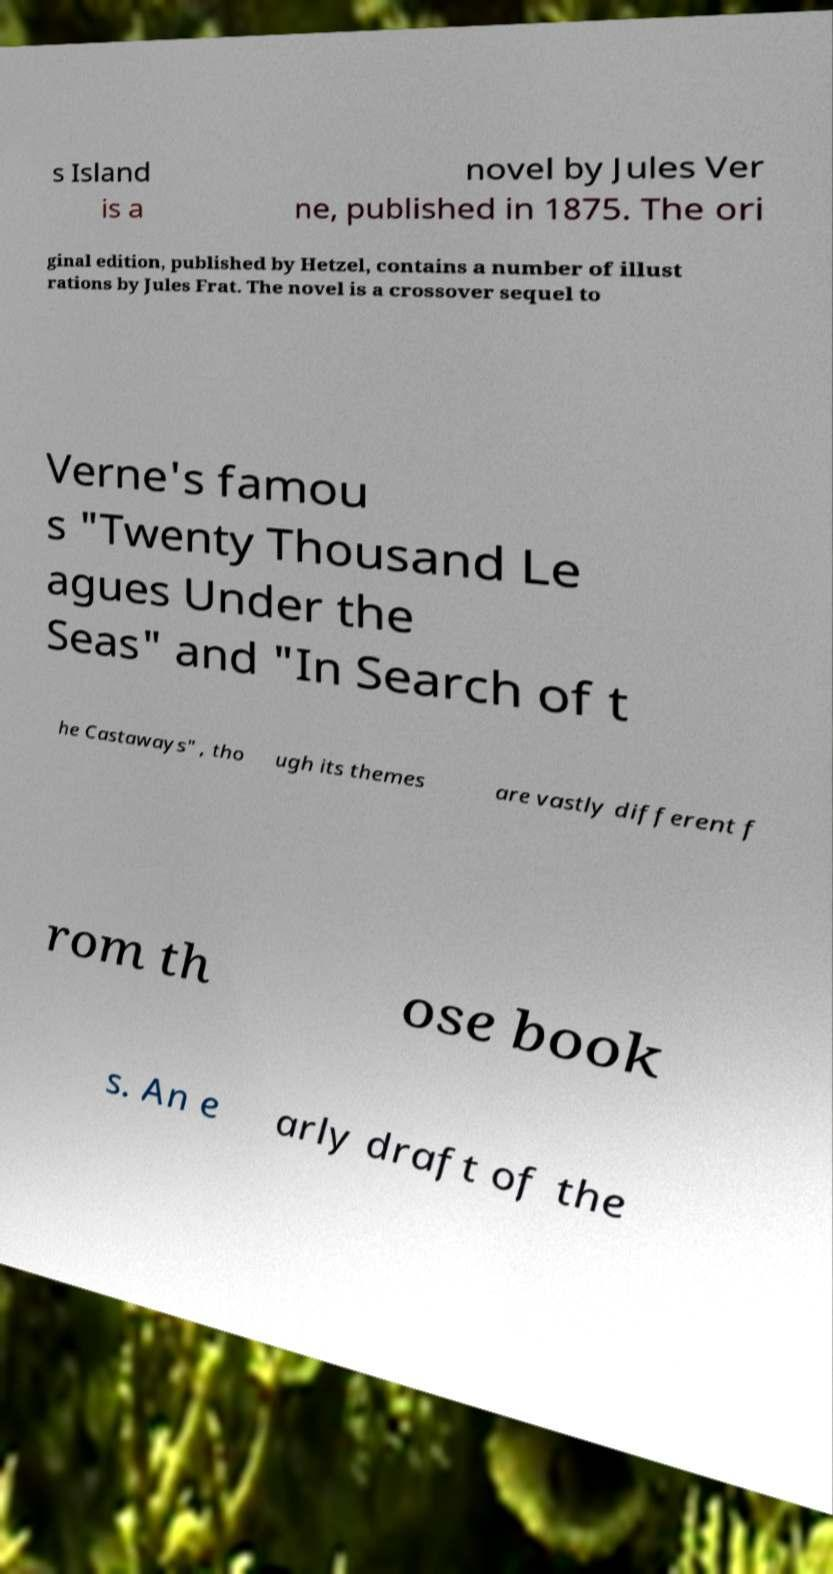What messages or text are displayed in this image? I need them in a readable, typed format. s Island is a novel by Jules Ver ne, published in 1875. The ori ginal edition, published by Hetzel, contains a number of illust rations by Jules Frat. The novel is a crossover sequel to Verne's famou s "Twenty Thousand Le agues Under the Seas" and "In Search of t he Castaways" , tho ugh its themes are vastly different f rom th ose book s. An e arly draft of the 